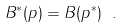Convert formula to latex. <formula><loc_0><loc_0><loc_500><loc_500>B ^ { \ast } ( p ) = B ( p ^ { \ast } ) \ .</formula> 